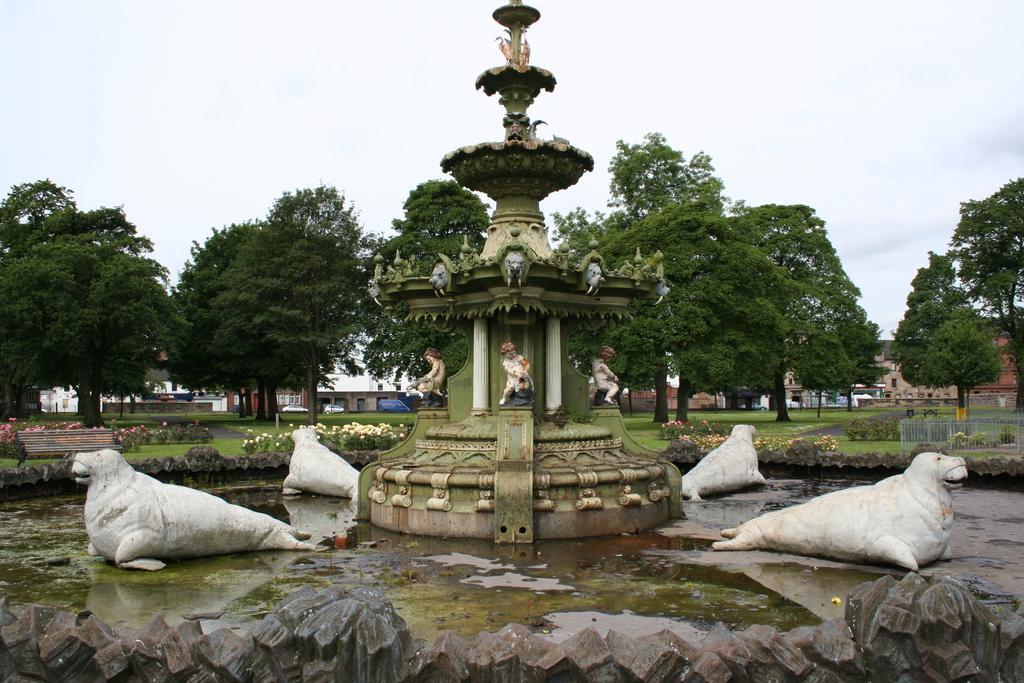Please provide a concise description of this image. This picture is clicked outside. In the foreground we can see the sculptures of the sea lions and the sculptures of the persons and we can see a fountain, the sculptures of animals and some other objects and we can see the water. In the background we can see the sky, trees, buildings, vehicles, green grass, plants, bench and many other objects. 